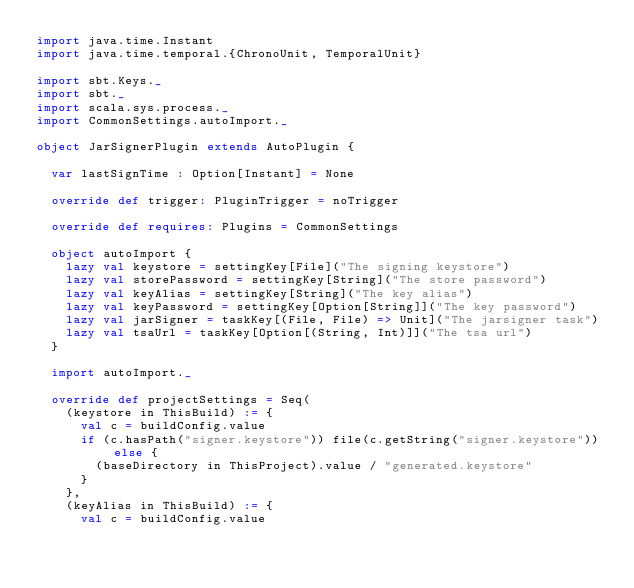<code> <loc_0><loc_0><loc_500><loc_500><_Scala_>import java.time.Instant
import java.time.temporal.{ChronoUnit, TemporalUnit}

import sbt.Keys._
import sbt._
import scala.sys.process._
import CommonSettings.autoImport._

object JarSignerPlugin extends AutoPlugin {

  var lastSignTime : Option[Instant] = None

  override def trigger: PluginTrigger = noTrigger

  override def requires: Plugins = CommonSettings

  object autoImport {
    lazy val keystore = settingKey[File]("The signing keystore")
    lazy val storePassword = settingKey[String]("The store password")
    lazy val keyAlias = settingKey[String]("The key alias")
    lazy val keyPassword = settingKey[Option[String]]("The key password")
    lazy val jarSigner = taskKey[(File, File) => Unit]("The jarsigner task")
    lazy val tsaUrl = taskKey[Option[(String, Int)]]("The tsa url")
  }

  import autoImport._

  override def projectSettings = Seq(
    (keystore in ThisBuild) := {
      val c = buildConfig.value
      if (c.hasPath("signer.keystore")) file(c.getString("signer.keystore")) else {
        (baseDirectory in ThisProject).value / "generated.keystore"
      }
    },
    (keyAlias in ThisBuild) := {
      val c = buildConfig.value</code> 